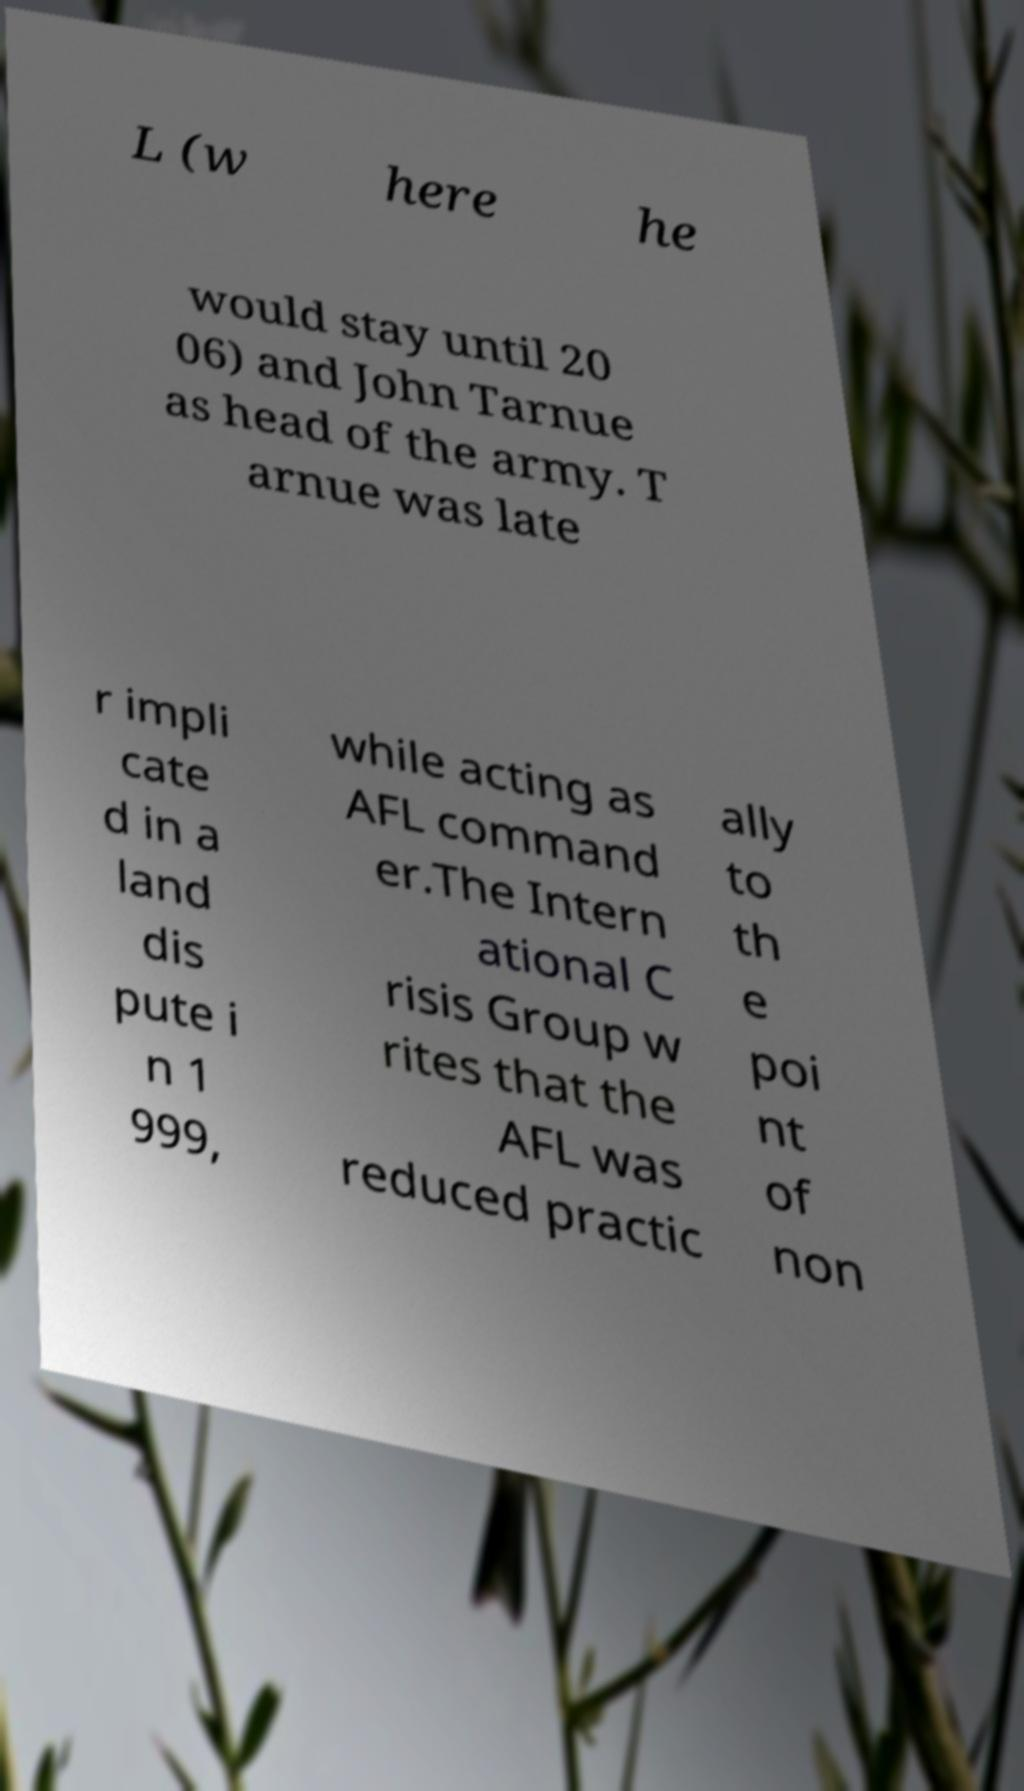Could you assist in decoding the text presented in this image and type it out clearly? L (w here he would stay until 20 06) and John Tarnue as head of the army. T arnue was late r impli cate d in a land dis pute i n 1 999, while acting as AFL command er.The Intern ational C risis Group w rites that the AFL was reduced practic ally to th e poi nt of non 